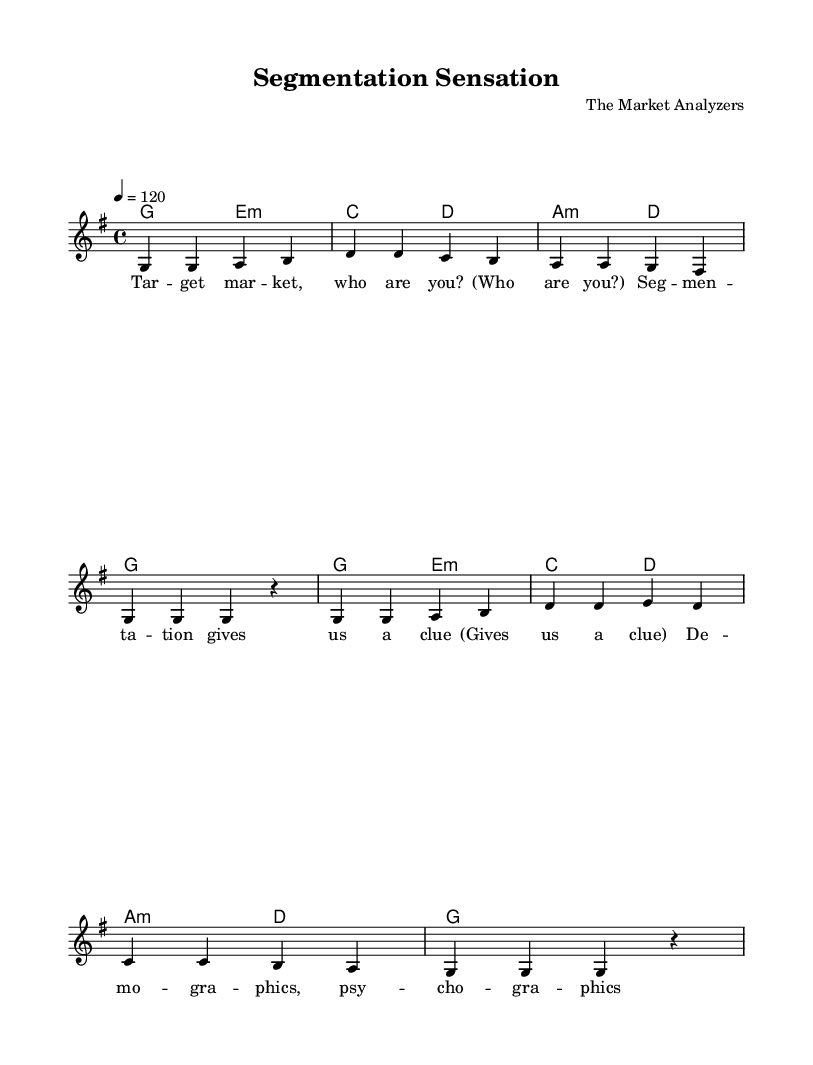What is the key signature of this music? The key signature is G major, which has one sharp (F#). This can be identified by looking at the key signature indicated at the beginning of the staff.
Answer: G major What is the time signature of this piece? The time signature is 4/4, which means there are four beats per measure and the quarter note gets one beat. This is marked at the beginning of the sheet music after the key signature.
Answer: 4/4 What is the tempo marking of this music? The tempo marking is 120, indicating a speed of 120 beats per minute. This is specified in the tempo notation section at the start of the score.
Answer: 120 How many measures are in the verse of the song? The verse consists of eight measures, which can be counted by looking at the divisions between each set of notes in the melody line.
Answer: 8 What is the last note of the melody in the first section? The last note of the melody in the first section is a rest, which is indicated by the symbol for rest following the notes in that section.
Answer: rest How do the harmonies change across the sections of the song? The harmonies follow a pattern, alternating between G, E minor, C, D, A minor, and back to G, reflecting a typical chord progression in pop music. This can be analyzed by looking at the changes in chord symbols throughout the piece.
Answer: Alternates What is the thematic focus of the lyrics in the song? The thematic focus of the lyrics centers around market segmentation and consumer behavior as reflected in phrases describing target markets and behavior patterns. This can be inferred from the words used in the lyrics section.
Answer: Market segmentation 